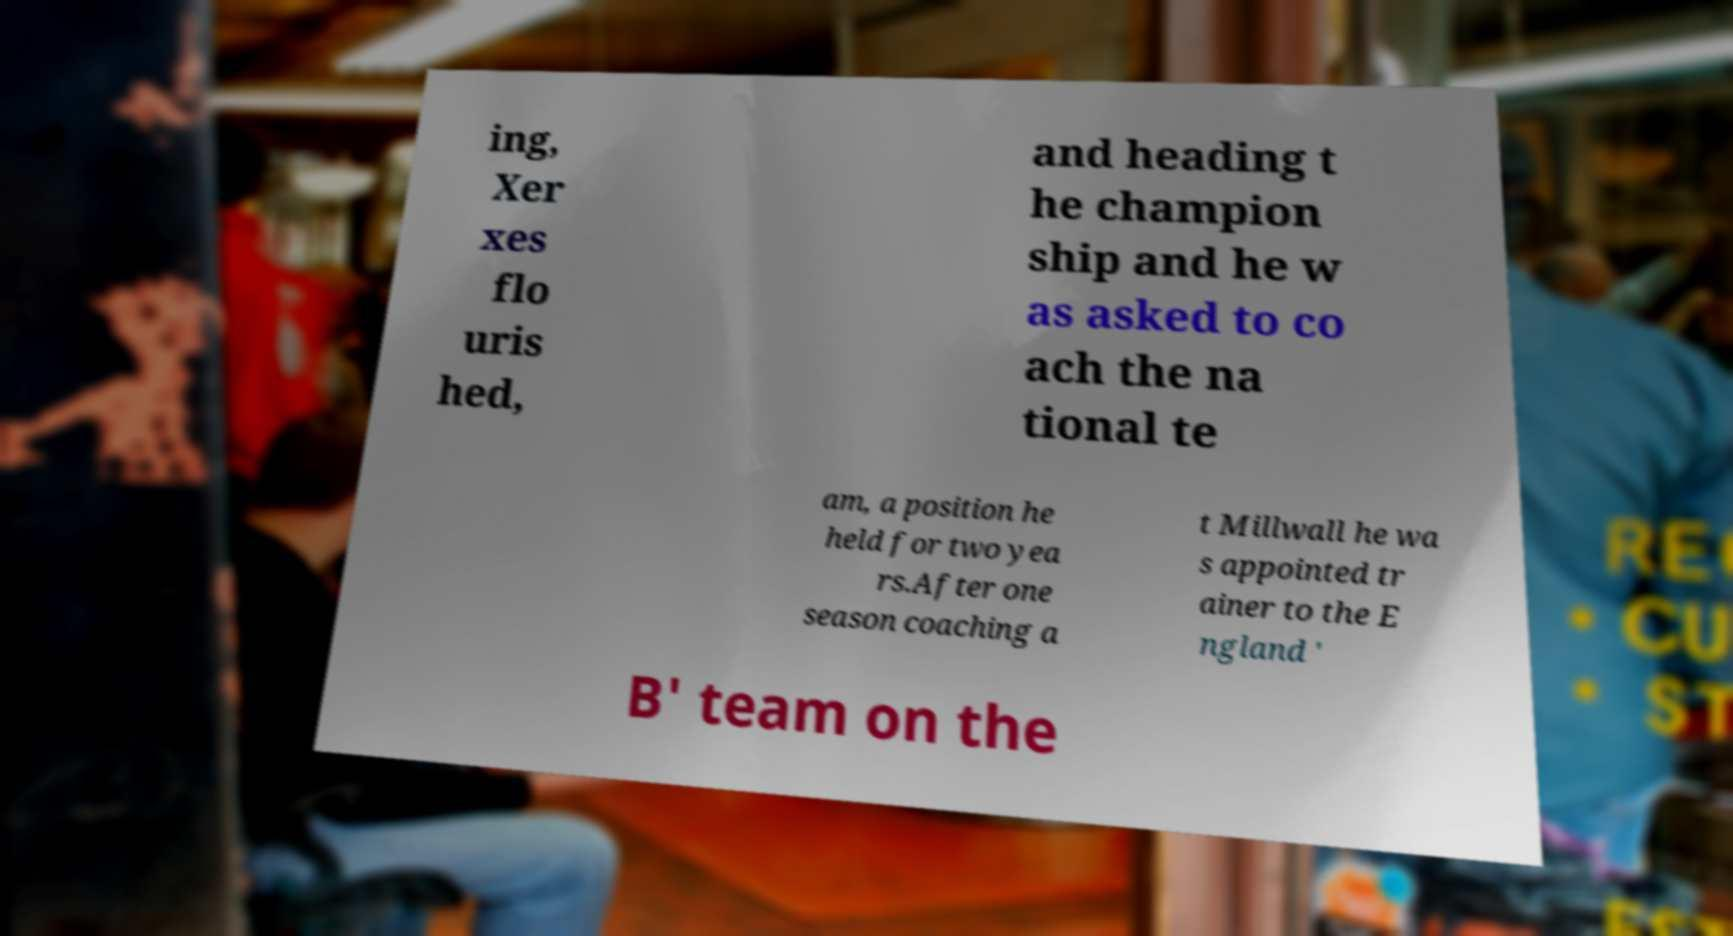Please read and relay the text visible in this image. What does it say? ing, Xer xes flo uris hed, and heading t he champion ship and he w as asked to co ach the na tional te am, a position he held for two yea rs.After one season coaching a t Millwall he wa s appointed tr ainer to the E ngland ' B' team on the 